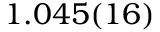Convert formula to latex. <formula><loc_0><loc_0><loc_500><loc_500>1 . 0 4 5 ( 1 6 )</formula> 